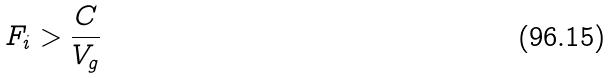<formula> <loc_0><loc_0><loc_500><loc_500>F _ { i } > \frac { C } { V _ { g } }</formula> 